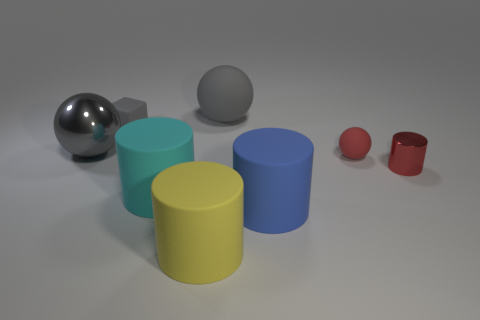There is a rubber sphere that is on the right side of the ball that is behind the small object behind the tiny red rubber thing; what is its color?
Offer a very short reply. Red. The matte cube is what color?
Offer a very short reply. Gray. Are there more large gray metallic things to the left of the cyan matte thing than yellow objects right of the blue matte cylinder?
Your answer should be very brief. Yes. Do the big blue matte object and the metal thing in front of the tiny red ball have the same shape?
Offer a terse response. Yes. There is a matte sphere that is in front of the metal ball; is its size the same as the matte sphere that is behind the large gray metal ball?
Ensure brevity in your answer.  No. There is a tiny red object left of the metallic thing right of the small red ball; are there any balls that are to the left of it?
Your answer should be compact. Yes. Is the number of big metal spheres on the right side of the tiny sphere less than the number of gray metallic balls right of the big blue matte object?
Make the answer very short. No. What shape is the blue thing that is the same material as the tiny sphere?
Your answer should be compact. Cylinder. There is a metal object on the right side of the gray sphere that is left of the gray thing behind the tiny gray thing; what is its size?
Keep it short and to the point. Small. Are there more big cyan rubber objects than small purple shiny cylinders?
Provide a succinct answer. Yes. 